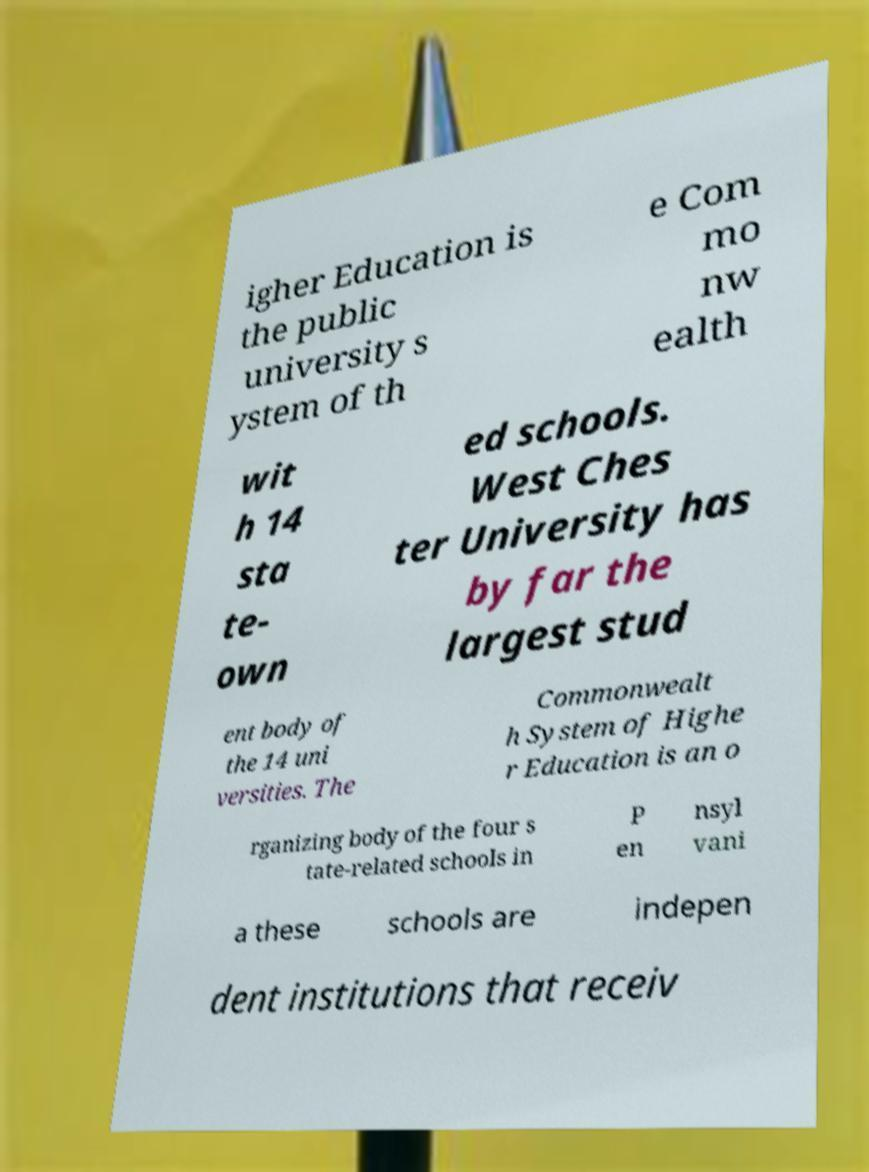What messages or text are displayed in this image? I need them in a readable, typed format. igher Education is the public university s ystem of th e Com mo nw ealth wit h 14 sta te- own ed schools. West Ches ter University has by far the largest stud ent body of the 14 uni versities. The Commonwealt h System of Highe r Education is an o rganizing body of the four s tate-related schools in P en nsyl vani a these schools are indepen dent institutions that receiv 